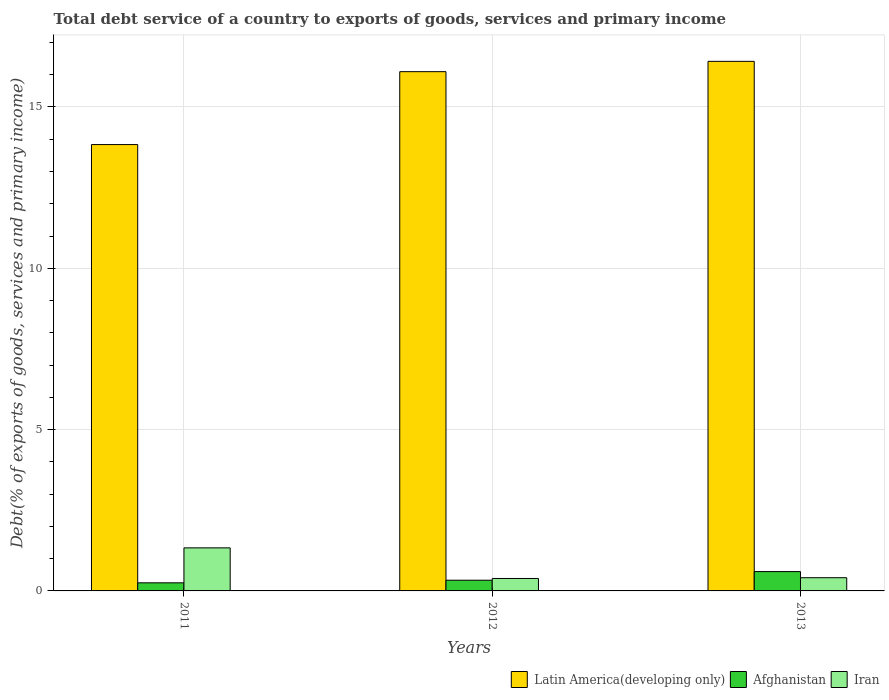How many groups of bars are there?
Keep it short and to the point. 3. How many bars are there on the 1st tick from the left?
Make the answer very short. 3. How many bars are there on the 3rd tick from the right?
Your answer should be very brief. 3. What is the total debt service in Iran in 2011?
Your answer should be compact. 1.33. Across all years, what is the maximum total debt service in Iran?
Offer a terse response. 1.33. Across all years, what is the minimum total debt service in Afghanistan?
Offer a terse response. 0.25. In which year was the total debt service in Latin America(developing only) maximum?
Provide a short and direct response. 2013. In which year was the total debt service in Iran minimum?
Make the answer very short. 2012. What is the total total debt service in Afghanistan in the graph?
Provide a short and direct response. 1.18. What is the difference between the total debt service in Latin America(developing only) in 2011 and that in 2013?
Your answer should be compact. -2.58. What is the difference between the total debt service in Afghanistan in 2011 and the total debt service in Iran in 2013?
Your answer should be compact. -0.16. What is the average total debt service in Afghanistan per year?
Offer a very short reply. 0.39. In the year 2013, what is the difference between the total debt service in Iran and total debt service in Afghanistan?
Ensure brevity in your answer.  -0.19. In how many years, is the total debt service in Afghanistan greater than 5 %?
Offer a terse response. 0. What is the ratio of the total debt service in Iran in 2012 to that in 2013?
Provide a short and direct response. 0.94. What is the difference between the highest and the second highest total debt service in Iran?
Your answer should be compact. 0.92. What is the difference between the highest and the lowest total debt service in Afghanistan?
Provide a succinct answer. 0.35. In how many years, is the total debt service in Iran greater than the average total debt service in Iran taken over all years?
Ensure brevity in your answer.  1. Is the sum of the total debt service in Afghanistan in 2011 and 2012 greater than the maximum total debt service in Iran across all years?
Ensure brevity in your answer.  No. What does the 3rd bar from the left in 2013 represents?
Offer a very short reply. Iran. What does the 3rd bar from the right in 2013 represents?
Provide a succinct answer. Latin America(developing only). What is the difference between two consecutive major ticks on the Y-axis?
Your answer should be very brief. 5. What is the title of the graph?
Provide a short and direct response. Total debt service of a country to exports of goods, services and primary income. Does "Channel Islands" appear as one of the legend labels in the graph?
Offer a terse response. No. What is the label or title of the X-axis?
Your answer should be very brief. Years. What is the label or title of the Y-axis?
Your answer should be very brief. Debt(% of exports of goods, services and primary income). What is the Debt(% of exports of goods, services and primary income) of Latin America(developing only) in 2011?
Provide a succinct answer. 13.83. What is the Debt(% of exports of goods, services and primary income) of Afghanistan in 2011?
Offer a very short reply. 0.25. What is the Debt(% of exports of goods, services and primary income) of Iran in 2011?
Your response must be concise. 1.33. What is the Debt(% of exports of goods, services and primary income) of Latin America(developing only) in 2012?
Keep it short and to the point. 16.09. What is the Debt(% of exports of goods, services and primary income) in Afghanistan in 2012?
Provide a short and direct response. 0.33. What is the Debt(% of exports of goods, services and primary income) in Iran in 2012?
Provide a short and direct response. 0.39. What is the Debt(% of exports of goods, services and primary income) in Latin America(developing only) in 2013?
Keep it short and to the point. 16.41. What is the Debt(% of exports of goods, services and primary income) of Afghanistan in 2013?
Provide a short and direct response. 0.6. What is the Debt(% of exports of goods, services and primary income) in Iran in 2013?
Give a very brief answer. 0.41. Across all years, what is the maximum Debt(% of exports of goods, services and primary income) of Latin America(developing only)?
Make the answer very short. 16.41. Across all years, what is the maximum Debt(% of exports of goods, services and primary income) of Afghanistan?
Ensure brevity in your answer.  0.6. Across all years, what is the maximum Debt(% of exports of goods, services and primary income) in Iran?
Offer a very short reply. 1.33. Across all years, what is the minimum Debt(% of exports of goods, services and primary income) of Latin America(developing only)?
Your answer should be very brief. 13.83. Across all years, what is the minimum Debt(% of exports of goods, services and primary income) in Afghanistan?
Make the answer very short. 0.25. Across all years, what is the minimum Debt(% of exports of goods, services and primary income) of Iran?
Your response must be concise. 0.39. What is the total Debt(% of exports of goods, services and primary income) of Latin America(developing only) in the graph?
Provide a short and direct response. 46.34. What is the total Debt(% of exports of goods, services and primary income) in Afghanistan in the graph?
Provide a short and direct response. 1.18. What is the total Debt(% of exports of goods, services and primary income) in Iran in the graph?
Offer a very short reply. 2.13. What is the difference between the Debt(% of exports of goods, services and primary income) in Latin America(developing only) in 2011 and that in 2012?
Give a very brief answer. -2.26. What is the difference between the Debt(% of exports of goods, services and primary income) in Afghanistan in 2011 and that in 2012?
Offer a terse response. -0.08. What is the difference between the Debt(% of exports of goods, services and primary income) of Iran in 2011 and that in 2012?
Your answer should be very brief. 0.95. What is the difference between the Debt(% of exports of goods, services and primary income) in Latin America(developing only) in 2011 and that in 2013?
Ensure brevity in your answer.  -2.58. What is the difference between the Debt(% of exports of goods, services and primary income) of Afghanistan in 2011 and that in 2013?
Keep it short and to the point. -0.35. What is the difference between the Debt(% of exports of goods, services and primary income) of Iran in 2011 and that in 2013?
Offer a very short reply. 0.93. What is the difference between the Debt(% of exports of goods, services and primary income) of Latin America(developing only) in 2012 and that in 2013?
Your answer should be very brief. -0.32. What is the difference between the Debt(% of exports of goods, services and primary income) of Afghanistan in 2012 and that in 2013?
Keep it short and to the point. -0.27. What is the difference between the Debt(% of exports of goods, services and primary income) in Iran in 2012 and that in 2013?
Provide a succinct answer. -0.02. What is the difference between the Debt(% of exports of goods, services and primary income) of Latin America(developing only) in 2011 and the Debt(% of exports of goods, services and primary income) of Afghanistan in 2012?
Make the answer very short. 13.5. What is the difference between the Debt(% of exports of goods, services and primary income) in Latin America(developing only) in 2011 and the Debt(% of exports of goods, services and primary income) in Iran in 2012?
Keep it short and to the point. 13.45. What is the difference between the Debt(% of exports of goods, services and primary income) in Afghanistan in 2011 and the Debt(% of exports of goods, services and primary income) in Iran in 2012?
Give a very brief answer. -0.13. What is the difference between the Debt(% of exports of goods, services and primary income) of Latin America(developing only) in 2011 and the Debt(% of exports of goods, services and primary income) of Afghanistan in 2013?
Keep it short and to the point. 13.23. What is the difference between the Debt(% of exports of goods, services and primary income) in Latin America(developing only) in 2011 and the Debt(% of exports of goods, services and primary income) in Iran in 2013?
Ensure brevity in your answer.  13.42. What is the difference between the Debt(% of exports of goods, services and primary income) of Afghanistan in 2011 and the Debt(% of exports of goods, services and primary income) of Iran in 2013?
Make the answer very short. -0.16. What is the difference between the Debt(% of exports of goods, services and primary income) of Latin America(developing only) in 2012 and the Debt(% of exports of goods, services and primary income) of Afghanistan in 2013?
Provide a short and direct response. 15.49. What is the difference between the Debt(% of exports of goods, services and primary income) of Latin America(developing only) in 2012 and the Debt(% of exports of goods, services and primary income) of Iran in 2013?
Offer a terse response. 15.68. What is the difference between the Debt(% of exports of goods, services and primary income) of Afghanistan in 2012 and the Debt(% of exports of goods, services and primary income) of Iran in 2013?
Offer a terse response. -0.08. What is the average Debt(% of exports of goods, services and primary income) in Latin America(developing only) per year?
Offer a very short reply. 15.45. What is the average Debt(% of exports of goods, services and primary income) of Afghanistan per year?
Offer a very short reply. 0.39. What is the average Debt(% of exports of goods, services and primary income) of Iran per year?
Keep it short and to the point. 0.71. In the year 2011, what is the difference between the Debt(% of exports of goods, services and primary income) in Latin America(developing only) and Debt(% of exports of goods, services and primary income) in Afghanistan?
Provide a short and direct response. 13.58. In the year 2011, what is the difference between the Debt(% of exports of goods, services and primary income) in Latin America(developing only) and Debt(% of exports of goods, services and primary income) in Iran?
Offer a very short reply. 12.5. In the year 2011, what is the difference between the Debt(% of exports of goods, services and primary income) in Afghanistan and Debt(% of exports of goods, services and primary income) in Iran?
Give a very brief answer. -1.08. In the year 2012, what is the difference between the Debt(% of exports of goods, services and primary income) of Latin America(developing only) and Debt(% of exports of goods, services and primary income) of Afghanistan?
Offer a very short reply. 15.76. In the year 2012, what is the difference between the Debt(% of exports of goods, services and primary income) in Latin America(developing only) and Debt(% of exports of goods, services and primary income) in Iran?
Provide a succinct answer. 15.71. In the year 2012, what is the difference between the Debt(% of exports of goods, services and primary income) in Afghanistan and Debt(% of exports of goods, services and primary income) in Iran?
Your answer should be very brief. -0.05. In the year 2013, what is the difference between the Debt(% of exports of goods, services and primary income) in Latin America(developing only) and Debt(% of exports of goods, services and primary income) in Afghanistan?
Your response must be concise. 15.81. In the year 2013, what is the difference between the Debt(% of exports of goods, services and primary income) in Latin America(developing only) and Debt(% of exports of goods, services and primary income) in Iran?
Ensure brevity in your answer.  16. In the year 2013, what is the difference between the Debt(% of exports of goods, services and primary income) in Afghanistan and Debt(% of exports of goods, services and primary income) in Iran?
Keep it short and to the point. 0.19. What is the ratio of the Debt(% of exports of goods, services and primary income) of Latin America(developing only) in 2011 to that in 2012?
Give a very brief answer. 0.86. What is the ratio of the Debt(% of exports of goods, services and primary income) in Afghanistan in 2011 to that in 2012?
Your answer should be compact. 0.76. What is the ratio of the Debt(% of exports of goods, services and primary income) in Iran in 2011 to that in 2012?
Your response must be concise. 3.46. What is the ratio of the Debt(% of exports of goods, services and primary income) of Latin America(developing only) in 2011 to that in 2013?
Your response must be concise. 0.84. What is the ratio of the Debt(% of exports of goods, services and primary income) in Afghanistan in 2011 to that in 2013?
Offer a terse response. 0.42. What is the ratio of the Debt(% of exports of goods, services and primary income) in Iran in 2011 to that in 2013?
Make the answer very short. 3.26. What is the ratio of the Debt(% of exports of goods, services and primary income) in Latin America(developing only) in 2012 to that in 2013?
Keep it short and to the point. 0.98. What is the ratio of the Debt(% of exports of goods, services and primary income) of Afghanistan in 2012 to that in 2013?
Your answer should be very brief. 0.55. What is the ratio of the Debt(% of exports of goods, services and primary income) of Iran in 2012 to that in 2013?
Keep it short and to the point. 0.94. What is the difference between the highest and the second highest Debt(% of exports of goods, services and primary income) in Latin America(developing only)?
Your answer should be compact. 0.32. What is the difference between the highest and the second highest Debt(% of exports of goods, services and primary income) in Afghanistan?
Give a very brief answer. 0.27. What is the difference between the highest and the second highest Debt(% of exports of goods, services and primary income) of Iran?
Give a very brief answer. 0.93. What is the difference between the highest and the lowest Debt(% of exports of goods, services and primary income) in Latin America(developing only)?
Ensure brevity in your answer.  2.58. What is the difference between the highest and the lowest Debt(% of exports of goods, services and primary income) of Afghanistan?
Offer a very short reply. 0.35. What is the difference between the highest and the lowest Debt(% of exports of goods, services and primary income) in Iran?
Ensure brevity in your answer.  0.95. 